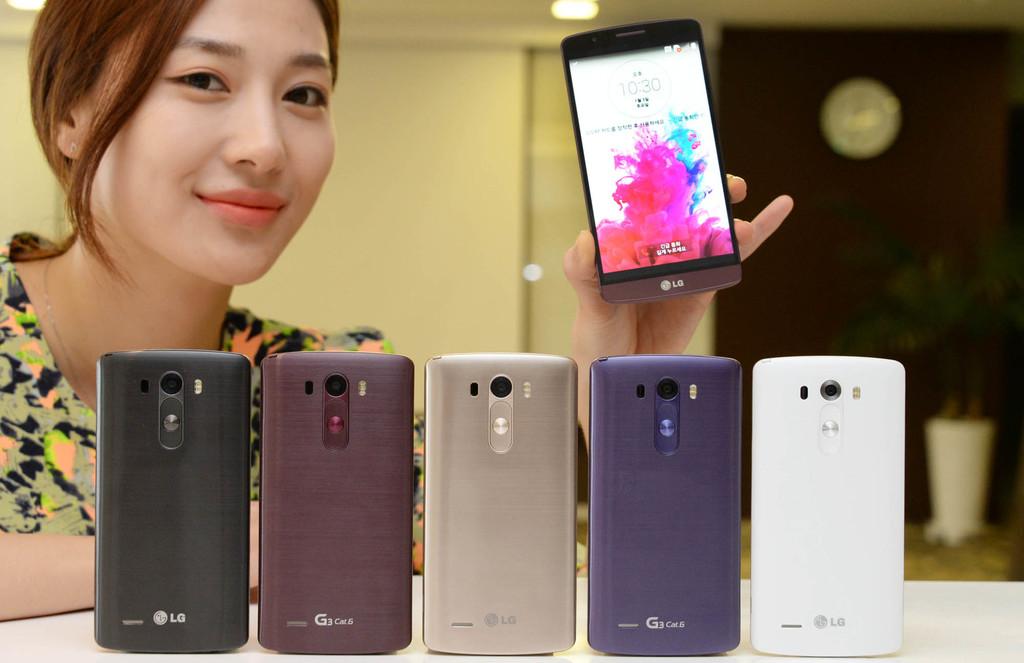What phone company is shown?
Your answer should be very brief. Lg. Does the phone say it's "10:30"?
Offer a terse response. Yes. 